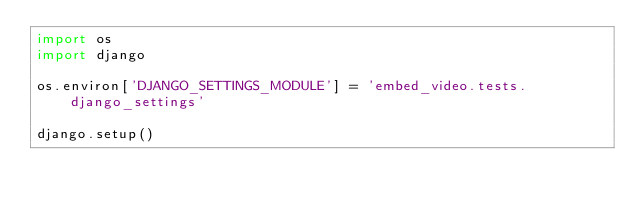<code> <loc_0><loc_0><loc_500><loc_500><_Python_>import os
import django

os.environ['DJANGO_SETTINGS_MODULE'] = 'embed_video.tests.django_settings'

django.setup()
</code> 